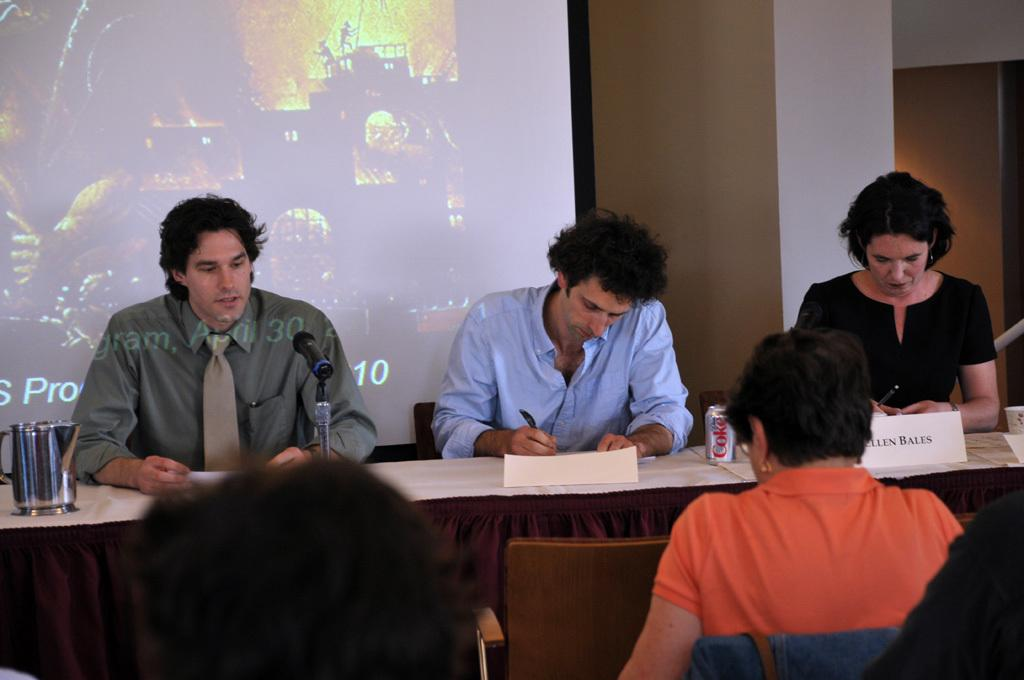What are the people in the image doing? The people in the image are sitting on chairs. What can be seen on the table in the image? There is a mic and a can on the table in the image. What is in the background of the image? There is a projector's screen in the background of the image. Can you see any roots growing from the chairs in the image? There are no roots visible in the image; the chairs are not connected to any plants or vegetation. 